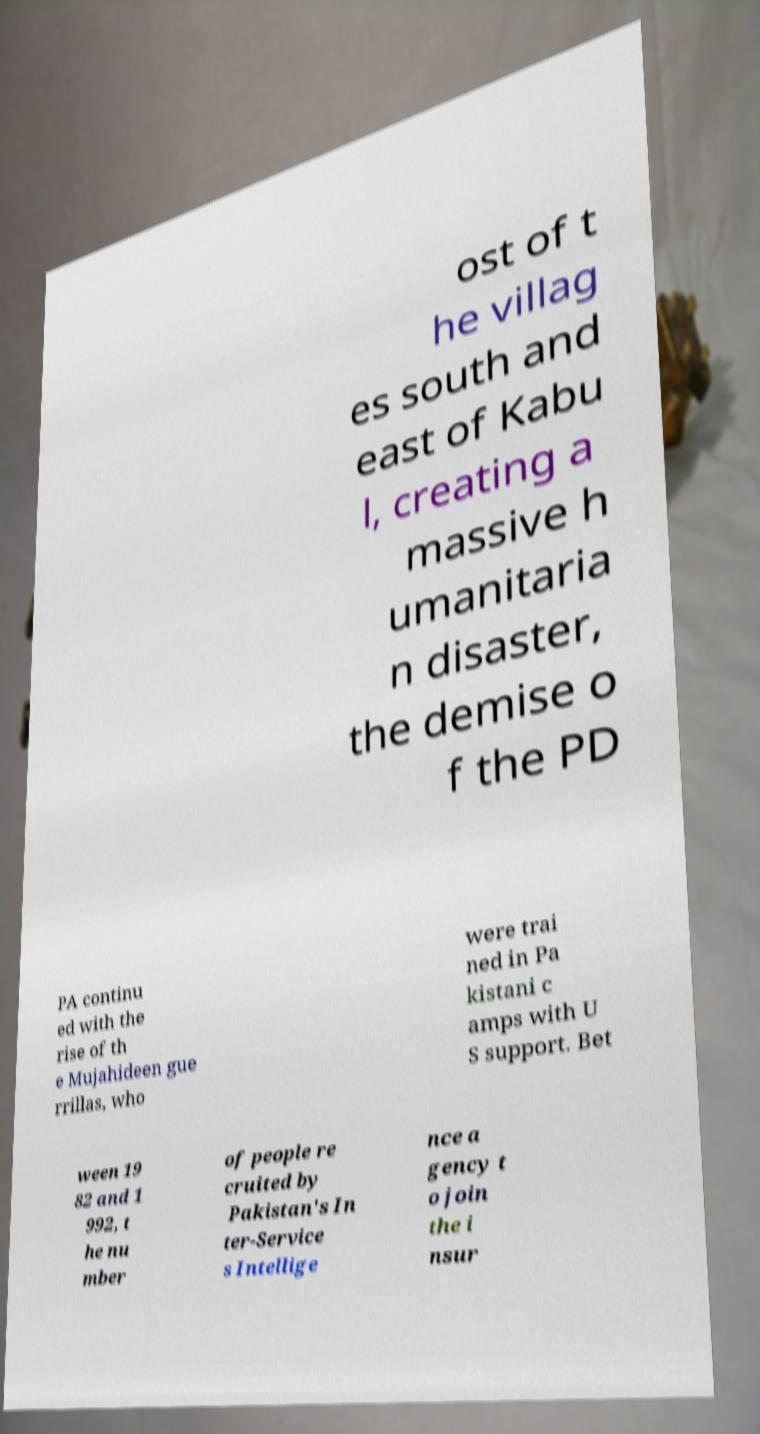There's text embedded in this image that I need extracted. Can you transcribe it verbatim? ost of t he villag es south and east of Kabu l, creating a massive h umanitaria n disaster, the demise o f the PD PA continu ed with the rise of th e Mujahideen gue rrillas, who were trai ned in Pa kistani c amps with U S support. Bet ween 19 82 and 1 992, t he nu mber of people re cruited by Pakistan's In ter-Service s Intellige nce a gency t o join the i nsur 